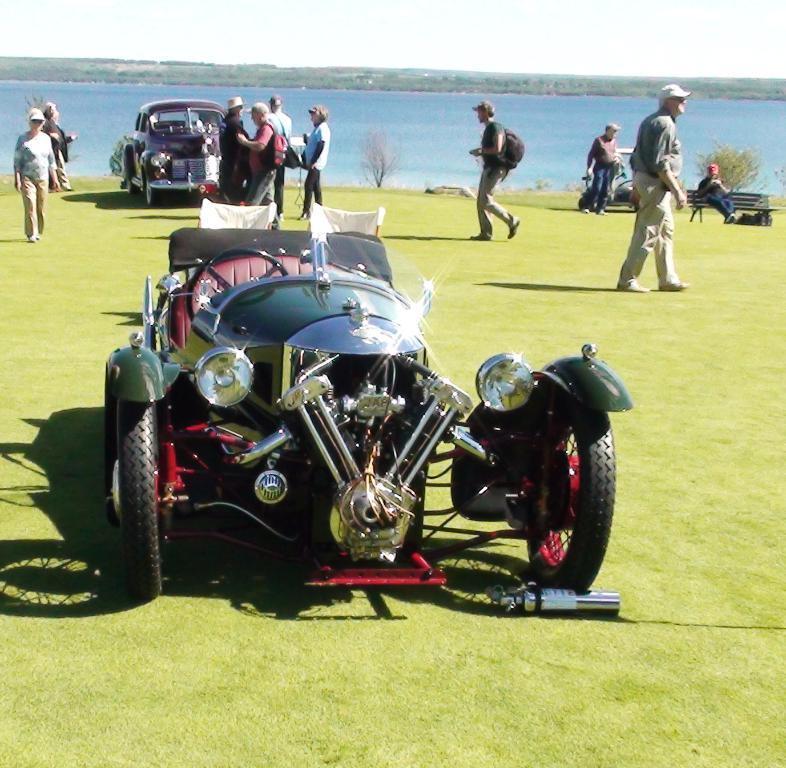In one or two sentences, can you explain what this image depicts? In this picture there are vehicles on the grass and there are group of people walking. On the right side of the image there is a person sitting on the bench. At the back there are trees. At the top there is sky. At the bottom there is water and there is grass. 